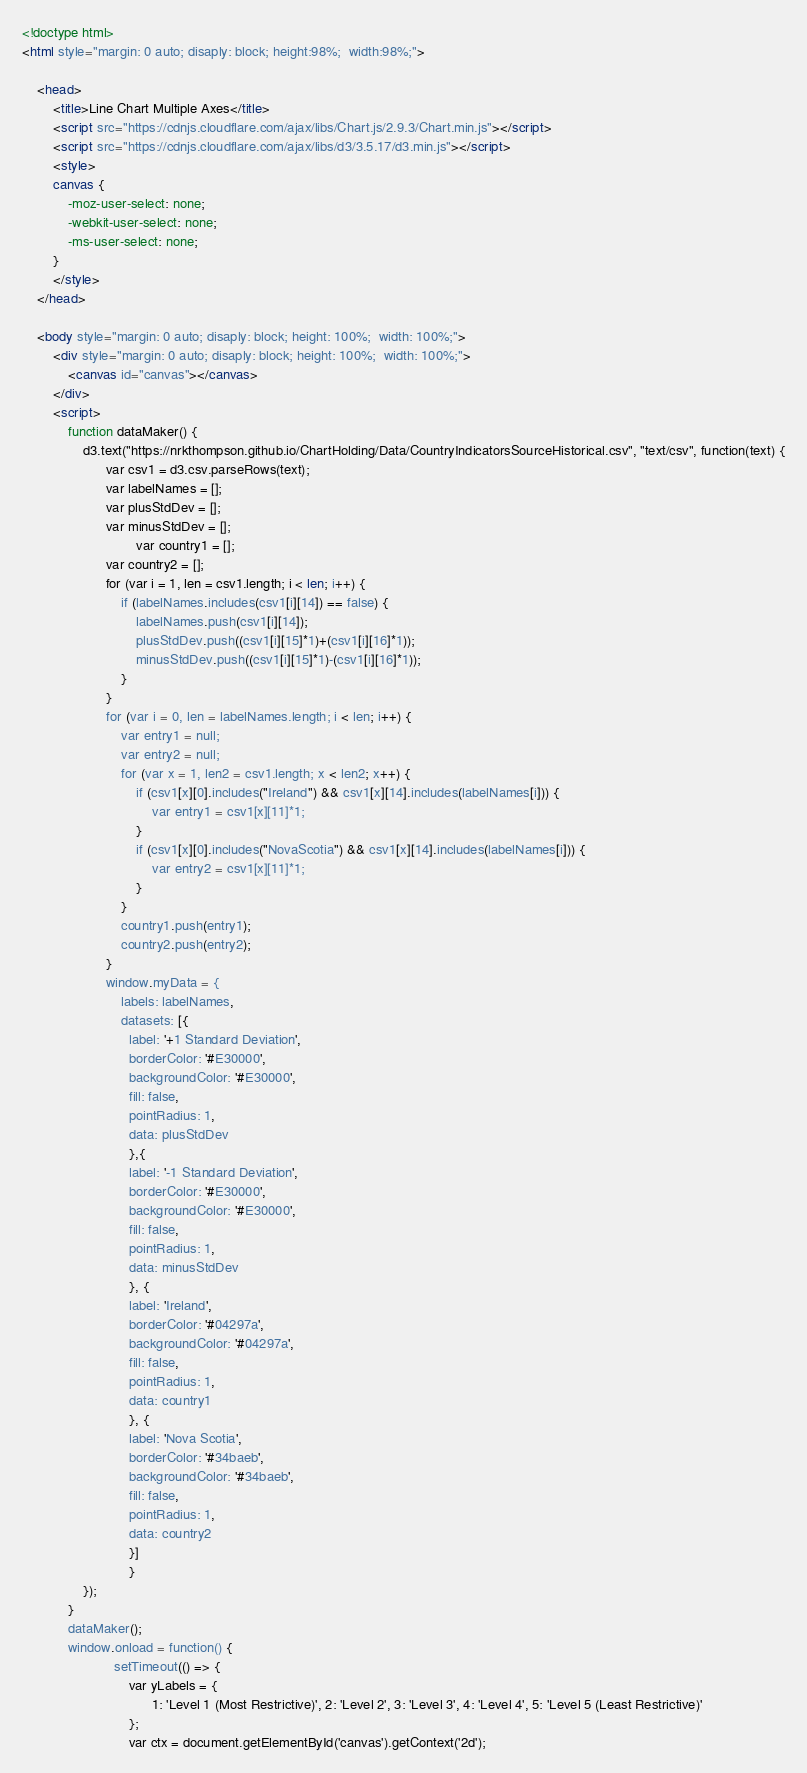<code> <loc_0><loc_0><loc_500><loc_500><_HTML_>
<!doctype html>
<html style="margin: 0 auto; disaply: block; height:98%;  width:98%;">

	<head>
		<title>Line Chart Multiple Axes</title>
		<script src="https://cdnjs.cloudflare.com/ajax/libs/Chart.js/2.9.3/Chart.min.js"></script>
		<script src="https://cdnjs.cloudflare.com/ajax/libs/d3/3.5.17/d3.min.js"></script>
		<style>
		canvas {
			-moz-user-select: none;
			-webkit-user-select: none;
			-ms-user-select: none;
		}
		</style>
	</head>

	<body style="margin: 0 auto; disaply: block; height: 100%;  width: 100%;">
		<div style="margin: 0 auto; disaply: block; height: 100%;  width: 100%;">
			<canvas id="canvas"></canvas>
		</div>
		<script>
			function dataMaker() {
				d3.text("https://nrkthompson.github.io/ChartHolding/Data/CountryIndicatorsSourceHistorical.csv", "text/csv", function(text) {
					  var csv1 = d3.csv.parseRows(text);
					  var labelNames = [];
					  var plusStdDev = [];
					  var minusStdDev = [];
            				  var country1 = [];
					  var country2 = [];
					  for (var i = 1, len = csv1.length; i < len; i++) {
						  if (labelNames.includes(csv1[i][14]) == false) {
							  labelNames.push(csv1[i][14]);
							  plusStdDev.push((csv1[i][15]*1)+(csv1[i][16]*1));
							  minusStdDev.push((csv1[i][15]*1)-(csv1[i][16]*1));
						  }
					  }
					  for (var i = 0, len = labelNames.length; i < len; i++) {
						  var entry1 = null;
						  var entry2 = null;
						  for (var x = 1, len2 = csv1.length; x < len2; x++) {
							  if (csv1[x][0].includes("Ireland") && csv1[x][14].includes(labelNames[i])) {
								  var entry1 = csv1[x][11]*1;
							  }
							  if (csv1[x][0].includes("NovaScotia") && csv1[x][14].includes(labelNames[i])) {
								  var entry2 = csv1[x][11]*1;
							  }
						  }
						  country1.push(entry1);
						  country2.push(entry2);
					  }
					  window.myData = {
						  labels: labelNames,
						  datasets: [{
						    label: '+1 Standard Deviation',
						    borderColor: '#E30000',
						    backgroundColor: '#E30000',
						    fill: false,
						    pointRadius: 1,
						    data: plusStdDev
						    },{
						    label: '-1 Standard Deviation',
						    borderColor: '#E30000',
						    backgroundColor: '#E30000',
						    fill: false,
						    pointRadius: 1,
						    data: minusStdDev
						    }, {
						    label: 'Ireland',
						    borderColor: '#04297a',
						    backgroundColor: '#04297a',
						    fill: false,
						    pointRadius: 1,
						    data: country1
						    }, {
						    label: 'Nova Scotia',
						    borderColor: '#34baeb',
						    backgroundColor: '#34baeb',
						    fill: false,
						    pointRadius: 1,
						    data: country2
						    }]
						    }  
				});
			}
			dataMaker();
			window.onload = function() {
						setTimeout(() => { 
							var yLabels = {
							      1: 'Level 1 (Most Restrictive)', 2: 'Level 2', 3: 'Level 3', 4: 'Level 4', 5: 'Level 5 (Least Restrictive)'
							};
							var ctx = document.getElementById('canvas').getContext('2d');</code> 